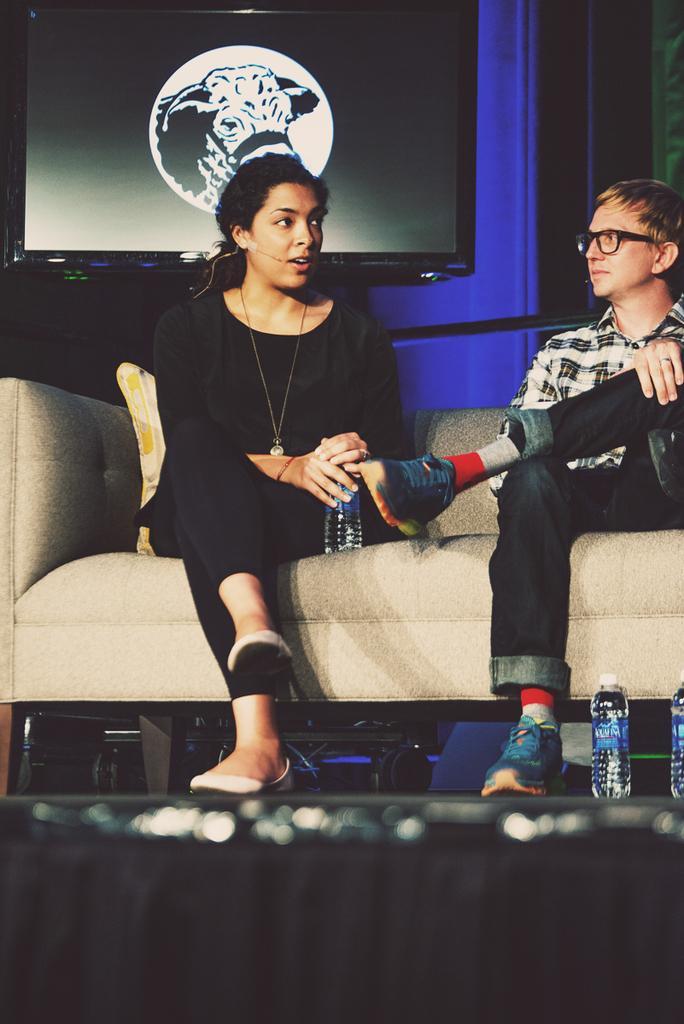Can you describe this image briefly? There is a woman and a man sitting on the sofa. She is holding a bottle with her hands. There are bottles. On the background there is a screen and this is floor. 